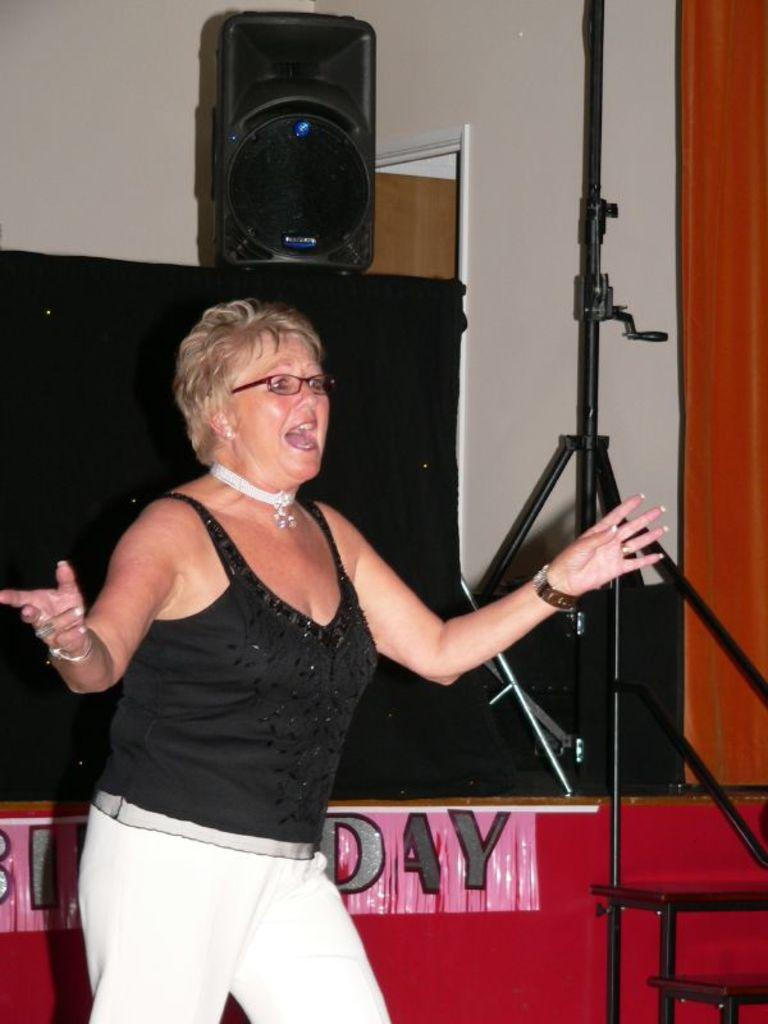<image>
Write a terse but informative summary of the picture. A woman standing in front of a stage on a birthday. 